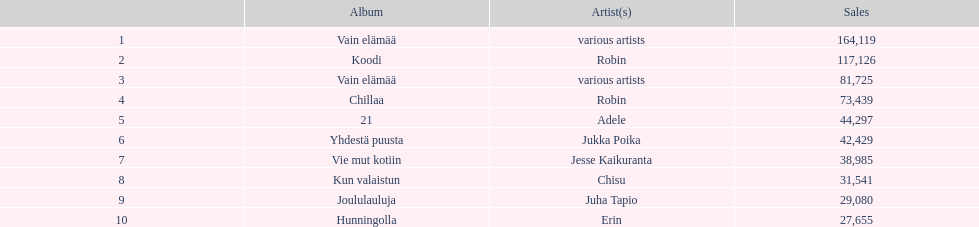What is the number of albums that sold over 50,000 copies this year? 4. 